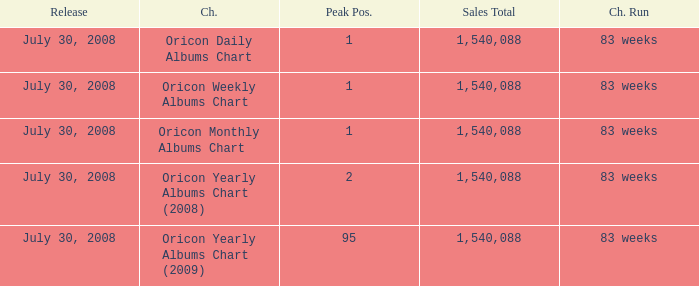Which Sales Total has a Chart of oricon monthly albums chart? 1540088.0. 